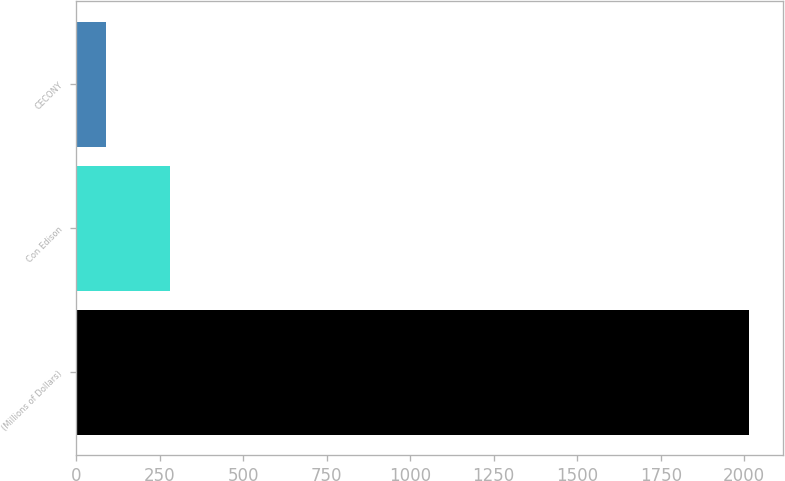Convert chart. <chart><loc_0><loc_0><loc_500><loc_500><bar_chart><fcel>(Millions of Dollars)<fcel>Con Edison<fcel>CECONY<nl><fcel>2015<fcel>281.6<fcel>89<nl></chart> 